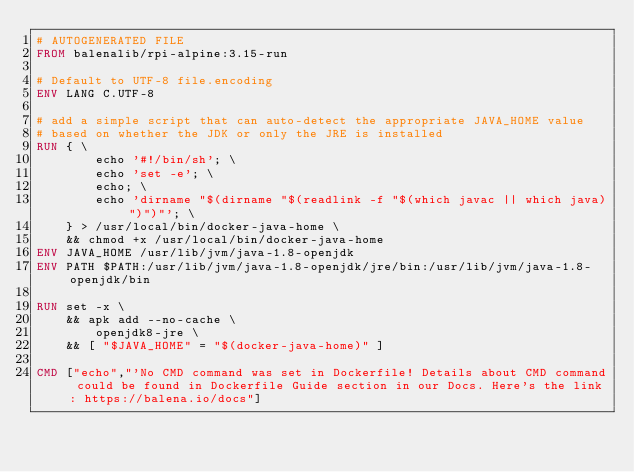Convert code to text. <code><loc_0><loc_0><loc_500><loc_500><_Dockerfile_># AUTOGENERATED FILE
FROM balenalib/rpi-alpine:3.15-run

# Default to UTF-8 file.encoding
ENV LANG C.UTF-8

# add a simple script that can auto-detect the appropriate JAVA_HOME value
# based on whether the JDK or only the JRE is installed
RUN { \
		echo '#!/bin/sh'; \
		echo 'set -e'; \
		echo; \
		echo 'dirname "$(dirname "$(readlink -f "$(which javac || which java)")")"'; \
	} > /usr/local/bin/docker-java-home \
	&& chmod +x /usr/local/bin/docker-java-home
ENV JAVA_HOME /usr/lib/jvm/java-1.8-openjdk
ENV PATH $PATH:/usr/lib/jvm/java-1.8-openjdk/jre/bin:/usr/lib/jvm/java-1.8-openjdk/bin

RUN set -x \
	&& apk add --no-cache \
		openjdk8-jre \
	&& [ "$JAVA_HOME" = "$(docker-java-home)" ]

CMD ["echo","'No CMD command was set in Dockerfile! Details about CMD command could be found in Dockerfile Guide section in our Docs. Here's the link: https://balena.io/docs"]
</code> 